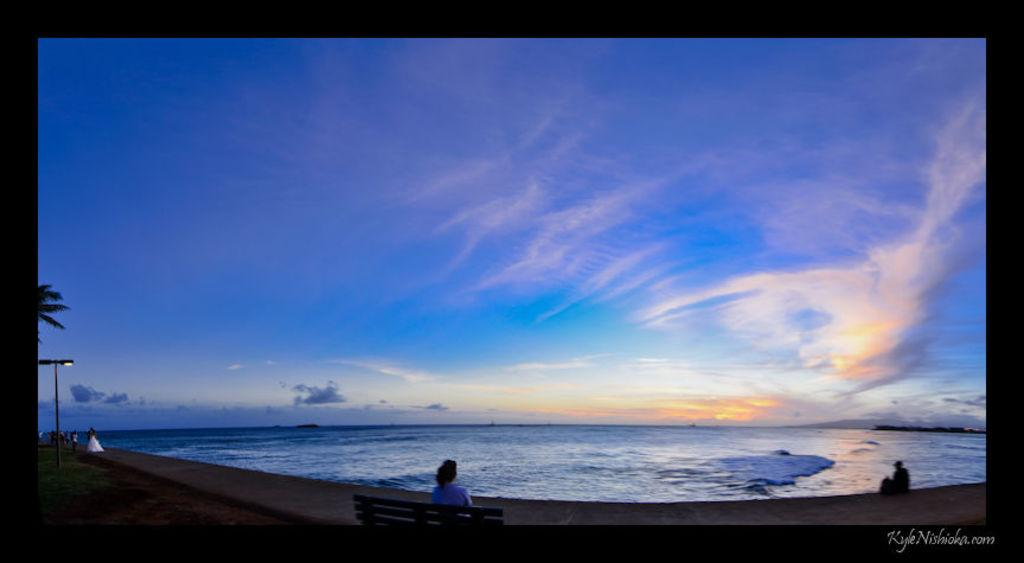Provide a one-sentence caption for the provided image. On KyleNishioka.com, a woman sits at the shore on a bench and looks out to the ocean and the beautiful blue sky. 